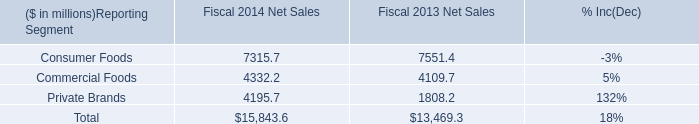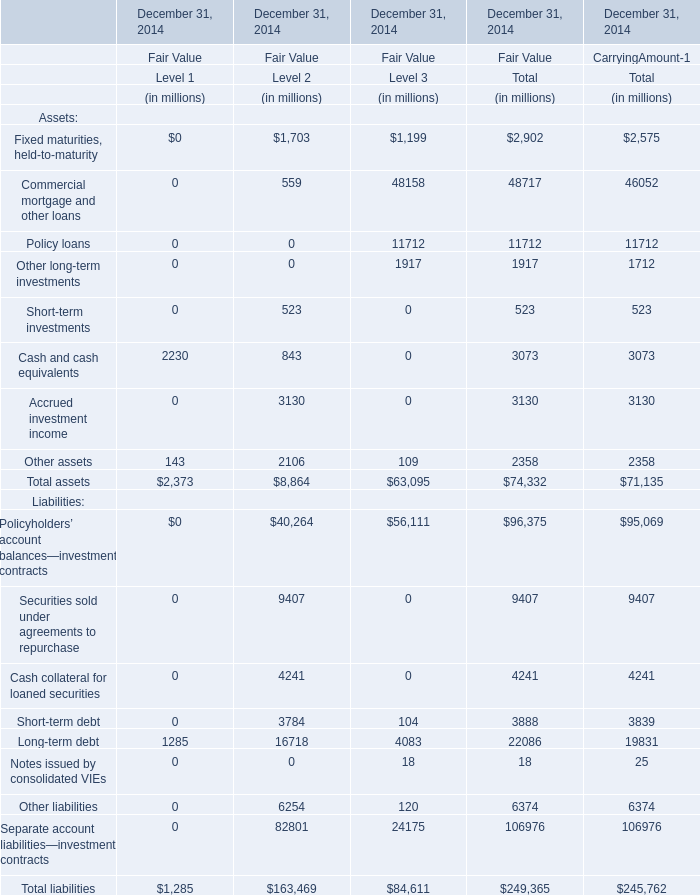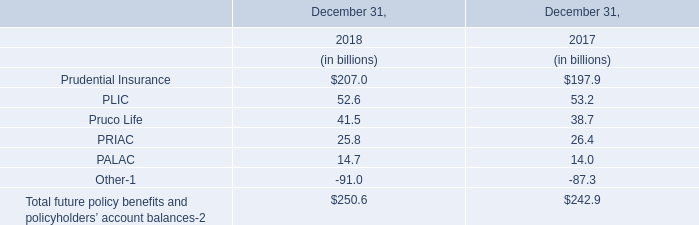Which Level is Fair Value for Total assets at December 31, 2014 the highest? 
Answer: 3. 